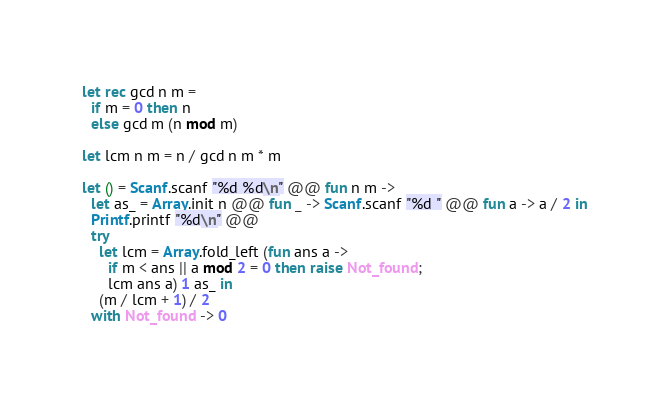Convert code to text. <code><loc_0><loc_0><loc_500><loc_500><_OCaml_>let rec gcd n m =
  if m = 0 then n
  else gcd m (n mod m)

let lcm n m = n / gcd n m * m

let () = Scanf.scanf "%d %d\n" @@ fun n m ->
  let as_ = Array.init n @@ fun _ -> Scanf.scanf "%d " @@ fun a -> a / 2 in
  Printf.printf "%d\n" @@
  try
    let lcm = Array.fold_left (fun ans a ->
      if m < ans || a mod 2 = 0 then raise Not_found;
      lcm ans a) 1 as_ in
    (m / lcm + 1) / 2
  with Not_found -> 0

</code> 